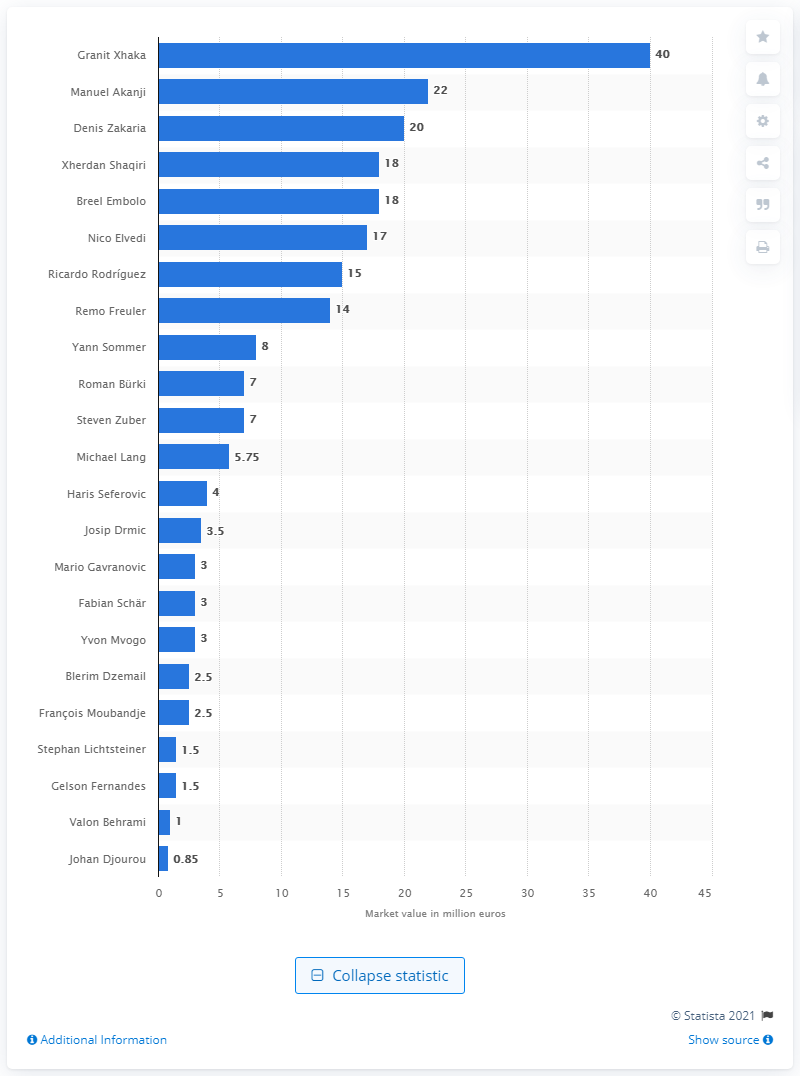Specify some key components in this picture. The most valuable player at the 2018 FIFA World Cup was Granit Xhaka. 